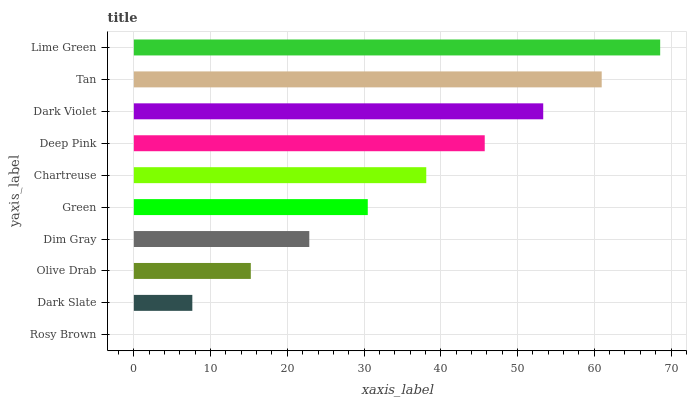Is Rosy Brown the minimum?
Answer yes or no. Yes. Is Lime Green the maximum?
Answer yes or no. Yes. Is Dark Slate the minimum?
Answer yes or no. No. Is Dark Slate the maximum?
Answer yes or no. No. Is Dark Slate greater than Rosy Brown?
Answer yes or no. Yes. Is Rosy Brown less than Dark Slate?
Answer yes or no. Yes. Is Rosy Brown greater than Dark Slate?
Answer yes or no. No. Is Dark Slate less than Rosy Brown?
Answer yes or no. No. Is Chartreuse the high median?
Answer yes or no. Yes. Is Green the low median?
Answer yes or no. Yes. Is Dim Gray the high median?
Answer yes or no. No. Is Tan the low median?
Answer yes or no. No. 